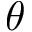<formula> <loc_0><loc_0><loc_500><loc_500>\theta</formula> 